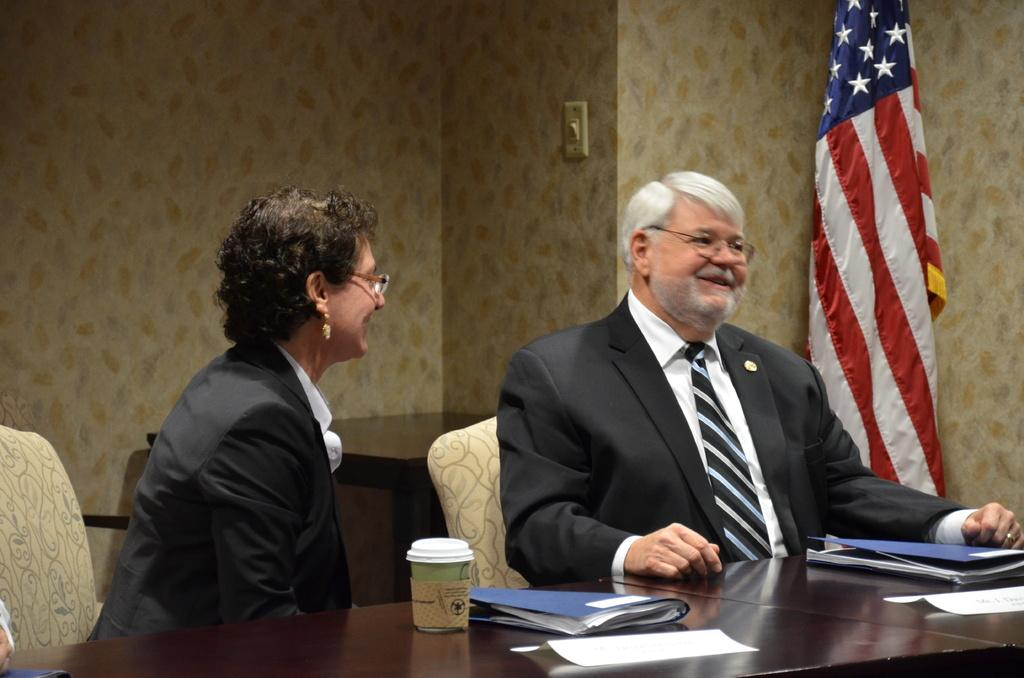How many people are sitting in the image? There are two people sitting on chairs in the image. What is the facial expression of the people in the image? The people are smiling. What items can be seen on the table in the image? There are files, papers, and a cup on the table. What can be seen in the background of the image? There is a flag, a wall, and another table in the background. What type of quartz is visible on the shirt of one of the people in the image? There is no quartz visible on the shirt of any person in the image. What is the relation between the two people in the image? The provided facts do not give any information about the relationship between the two people in the image. 